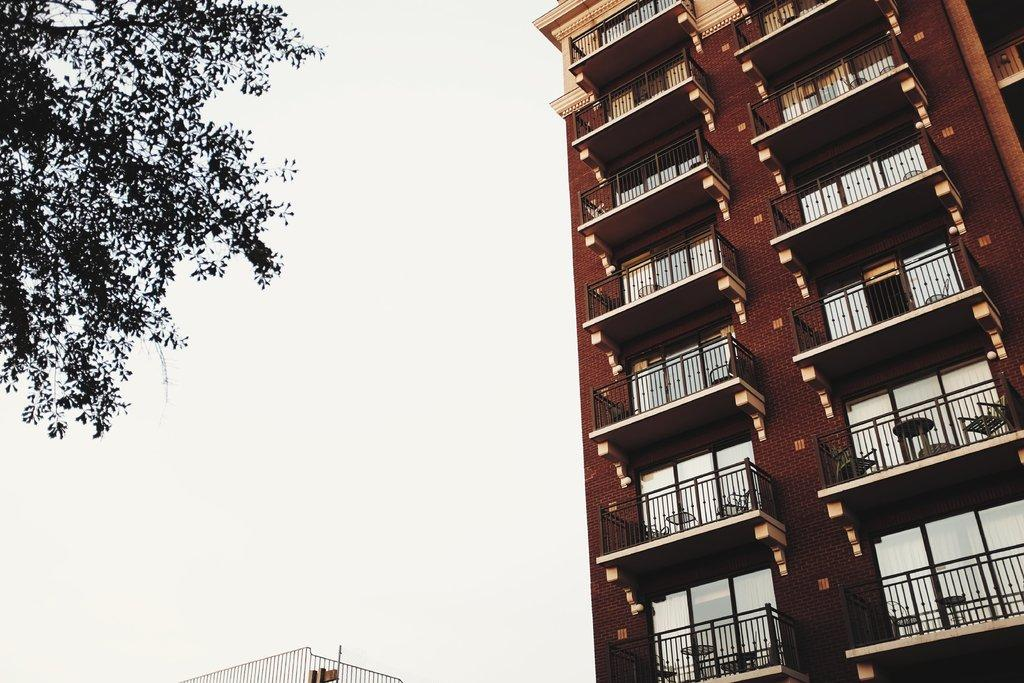What type of structure is present in the image? There is a tall building in the image. What can be seen near the tall building? There is a metal fence in the image. Where is the tree located in the image? The tree is on the left side of the image. How would you describe the sky in the image? The sky is cloudy in the image. Is there any quicksand visible in the image? No, there is no quicksand present in the image. What type of fruit can be seen hanging from the tree in the image? There is no fruit visible on the tree in the image. 